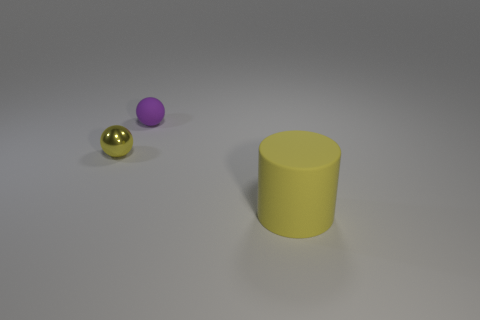Are the yellow object behind the large object and the yellow thing on the right side of the tiny matte sphere made of the same material?
Offer a terse response. No. Are there an equal number of small purple matte objects that are to the left of the small purple object and small yellow balls that are in front of the large yellow cylinder?
Your answer should be very brief. Yes. What number of cyan cylinders are the same material as the small purple sphere?
Make the answer very short. 0. There is a big matte thing that is the same color as the tiny shiny sphere; what is its shape?
Provide a succinct answer. Cylinder. There is a object on the left side of the sphere behind the yellow sphere; how big is it?
Ensure brevity in your answer.  Small. There is a small thing that is on the left side of the purple rubber thing; is its shape the same as the tiny thing right of the small yellow thing?
Make the answer very short. Yes. Are there the same number of yellow matte cylinders that are on the left side of the metallic thing and yellow cylinders?
Keep it short and to the point. No. What is the color of the small metal thing that is the same shape as the small rubber thing?
Offer a very short reply. Yellow. Are the thing to the right of the purple object and the purple object made of the same material?
Keep it short and to the point. Yes. How many tiny things are either yellow rubber things or red matte blocks?
Provide a short and direct response. 0. 